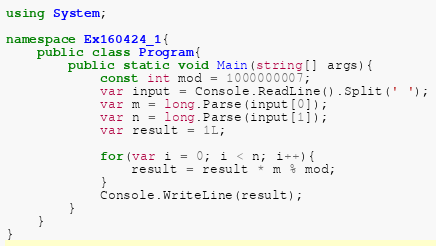Convert code to text. <code><loc_0><loc_0><loc_500><loc_500><_C#_>using System;

namespace Ex160424_1{
    public class Program{
        public static void Main(string[] args){
            const int mod = 1000000007;
            var input = Console.ReadLine().Split(' ');
            var m = long.Parse(input[0]);
            var n = long.Parse(input[1]);
            var result = 1L;

            for(var i = 0; i < n; i++){
                result = result * m % mod;
            }
            Console.WriteLine(result);
        }
    }
}</code> 